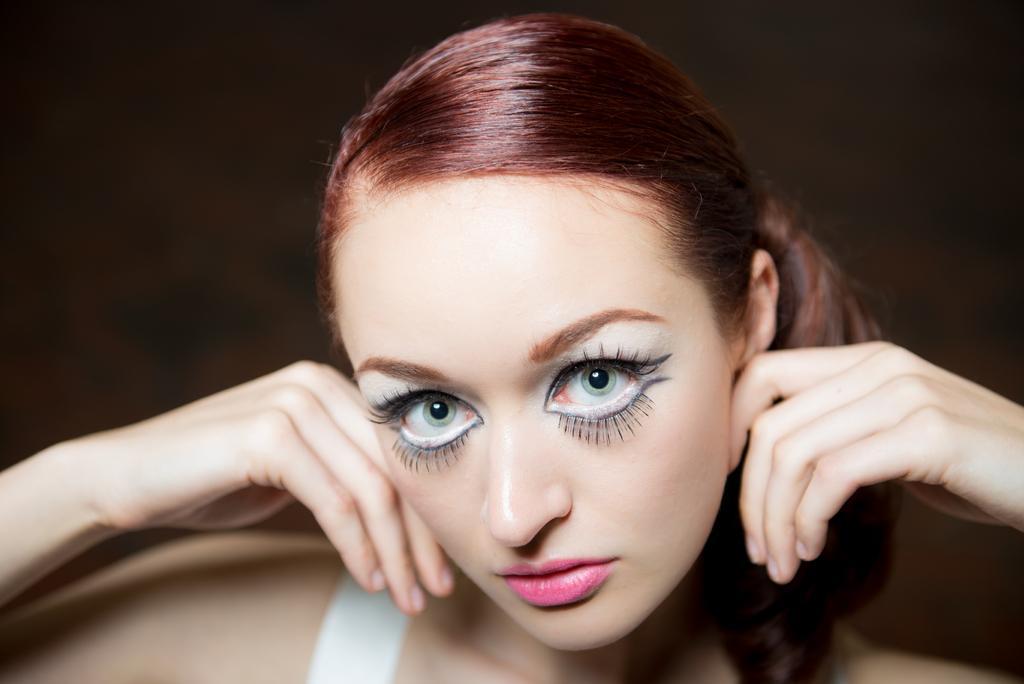Please provide a concise description of this image. In this picture there is a woman. She is wearing makeup like eyeliner, eyelashes and lipstick. 